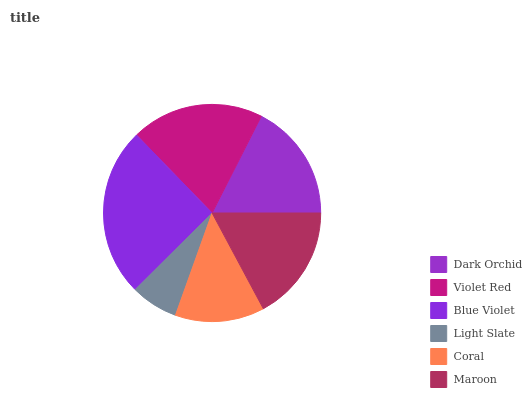Is Light Slate the minimum?
Answer yes or no. Yes. Is Blue Violet the maximum?
Answer yes or no. Yes. Is Violet Red the minimum?
Answer yes or no. No. Is Violet Red the maximum?
Answer yes or no. No. Is Violet Red greater than Dark Orchid?
Answer yes or no. Yes. Is Dark Orchid less than Violet Red?
Answer yes or no. Yes. Is Dark Orchid greater than Violet Red?
Answer yes or no. No. Is Violet Red less than Dark Orchid?
Answer yes or no. No. Is Dark Orchid the high median?
Answer yes or no. Yes. Is Maroon the low median?
Answer yes or no. Yes. Is Maroon the high median?
Answer yes or no. No. Is Coral the low median?
Answer yes or no. No. 